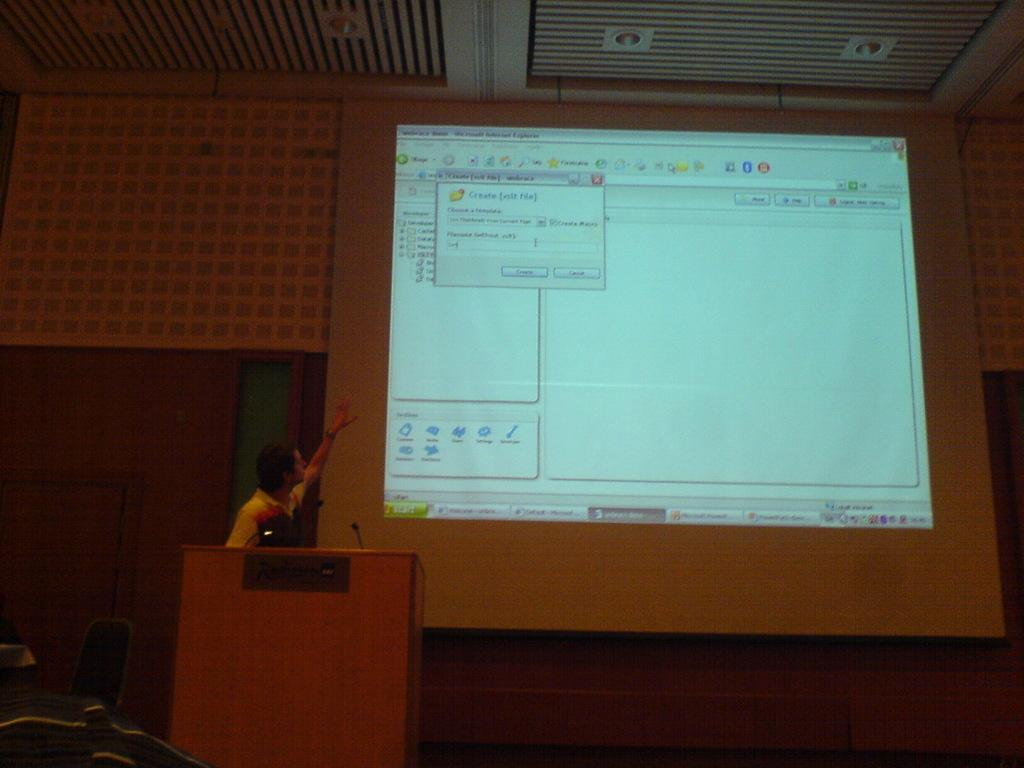<image>
Summarize the visual content of the image. A white computer monitor displays a screen to create a new file. 